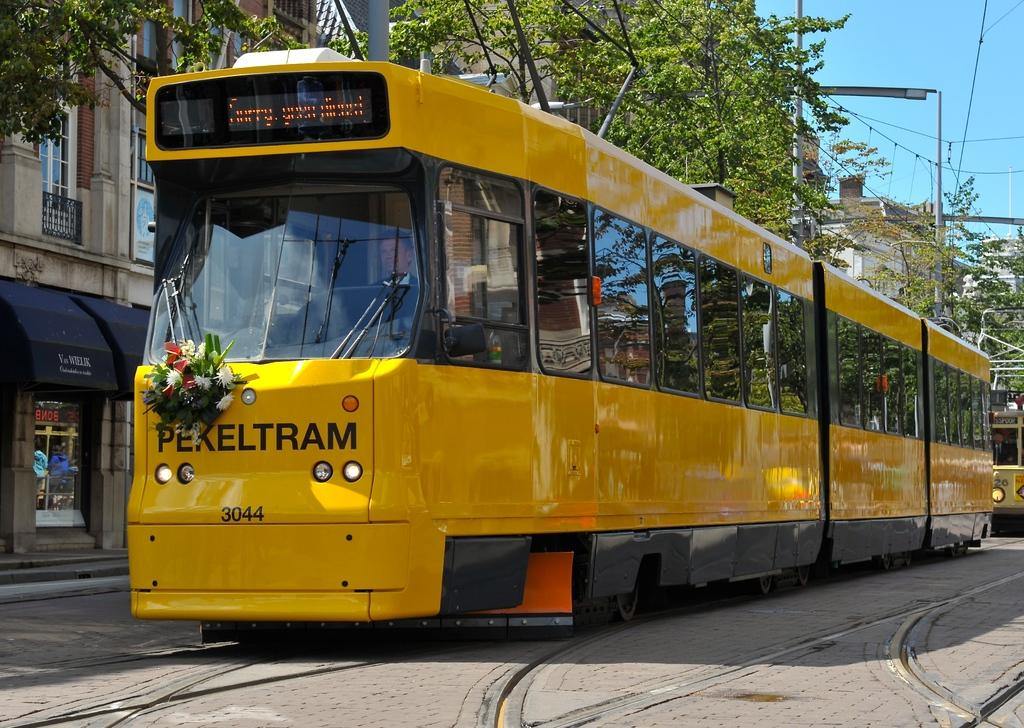What type of structures can be seen in the image? There are buildings in the image. What other natural elements are present in the image? There are trees in the image. What feature can be seen on some of the buildings? There are windows visible in the image. What type of transportation is present in the image? There are vehicles in the image. What type of establishments can be found in the image? There are stores in the image. What type of man-made objects can be seen in the image? There are poles in the image. What else can be seen attached to the poles? There are wires in the image. What is the color of the sky in the image? The sky is blue in color. Where is the coastline visible in the image? There is no coastline visible in the image. What type of religious building can be seen in the image? There is no religious building, such as a church, present in the image. What type of sporting equipment can be seen in the image? There is no sporting equipment, such as a baseball, present in the image. 